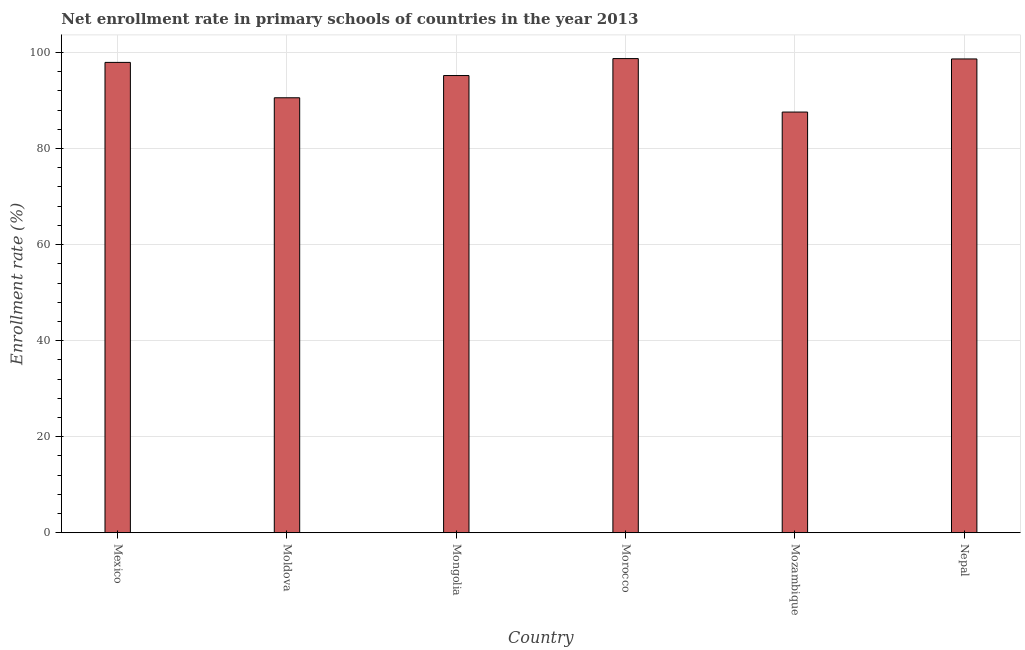Does the graph contain grids?
Ensure brevity in your answer.  Yes. What is the title of the graph?
Give a very brief answer. Net enrollment rate in primary schools of countries in the year 2013. What is the label or title of the X-axis?
Offer a terse response. Country. What is the label or title of the Y-axis?
Make the answer very short. Enrollment rate (%). What is the net enrollment rate in primary schools in Morocco?
Make the answer very short. 98.74. Across all countries, what is the maximum net enrollment rate in primary schools?
Give a very brief answer. 98.74. Across all countries, what is the minimum net enrollment rate in primary schools?
Keep it short and to the point. 87.61. In which country was the net enrollment rate in primary schools maximum?
Your response must be concise. Morocco. In which country was the net enrollment rate in primary schools minimum?
Make the answer very short. Mozambique. What is the sum of the net enrollment rate in primary schools?
Provide a short and direct response. 568.75. What is the difference between the net enrollment rate in primary schools in Morocco and Mozambique?
Your answer should be compact. 11.14. What is the average net enrollment rate in primary schools per country?
Provide a succinct answer. 94.79. What is the median net enrollment rate in primary schools?
Offer a terse response. 96.58. In how many countries, is the net enrollment rate in primary schools greater than 92 %?
Give a very brief answer. 4. What is the ratio of the net enrollment rate in primary schools in Moldova to that in Mozambique?
Your answer should be compact. 1.03. Is the difference between the net enrollment rate in primary schools in Mongolia and Morocco greater than the difference between any two countries?
Provide a short and direct response. No. What is the difference between the highest and the second highest net enrollment rate in primary schools?
Your answer should be compact. 0.08. Is the sum of the net enrollment rate in primary schools in Moldova and Nepal greater than the maximum net enrollment rate in primary schools across all countries?
Provide a short and direct response. Yes. What is the difference between the highest and the lowest net enrollment rate in primary schools?
Offer a terse response. 11.14. In how many countries, is the net enrollment rate in primary schools greater than the average net enrollment rate in primary schools taken over all countries?
Your answer should be very brief. 4. How many bars are there?
Offer a terse response. 6. What is the Enrollment rate (%) in Mexico?
Your response must be concise. 97.95. What is the Enrollment rate (%) of Moldova?
Your answer should be very brief. 90.58. What is the Enrollment rate (%) in Mongolia?
Offer a very short reply. 95.21. What is the Enrollment rate (%) in Morocco?
Offer a very short reply. 98.74. What is the Enrollment rate (%) in Mozambique?
Keep it short and to the point. 87.61. What is the Enrollment rate (%) of Nepal?
Your answer should be very brief. 98.67. What is the difference between the Enrollment rate (%) in Mexico and Moldova?
Provide a short and direct response. 7.37. What is the difference between the Enrollment rate (%) in Mexico and Mongolia?
Provide a succinct answer. 2.74. What is the difference between the Enrollment rate (%) in Mexico and Morocco?
Your answer should be compact. -0.8. What is the difference between the Enrollment rate (%) in Mexico and Mozambique?
Your response must be concise. 10.34. What is the difference between the Enrollment rate (%) in Mexico and Nepal?
Provide a succinct answer. -0.72. What is the difference between the Enrollment rate (%) in Moldova and Mongolia?
Ensure brevity in your answer.  -4.63. What is the difference between the Enrollment rate (%) in Moldova and Morocco?
Offer a very short reply. -8.16. What is the difference between the Enrollment rate (%) in Moldova and Mozambique?
Ensure brevity in your answer.  2.97. What is the difference between the Enrollment rate (%) in Moldova and Nepal?
Provide a succinct answer. -8.09. What is the difference between the Enrollment rate (%) in Mongolia and Morocco?
Offer a terse response. -3.53. What is the difference between the Enrollment rate (%) in Mongolia and Mozambique?
Your answer should be very brief. 7.6. What is the difference between the Enrollment rate (%) in Mongolia and Nepal?
Ensure brevity in your answer.  -3.46. What is the difference between the Enrollment rate (%) in Morocco and Mozambique?
Offer a very short reply. 11.14. What is the difference between the Enrollment rate (%) in Morocco and Nepal?
Offer a very short reply. 0.08. What is the difference between the Enrollment rate (%) in Mozambique and Nepal?
Provide a short and direct response. -11.06. What is the ratio of the Enrollment rate (%) in Mexico to that in Moldova?
Offer a terse response. 1.08. What is the ratio of the Enrollment rate (%) in Mexico to that in Mongolia?
Your answer should be compact. 1.03. What is the ratio of the Enrollment rate (%) in Mexico to that in Morocco?
Keep it short and to the point. 0.99. What is the ratio of the Enrollment rate (%) in Mexico to that in Mozambique?
Give a very brief answer. 1.12. What is the ratio of the Enrollment rate (%) in Moldova to that in Mongolia?
Provide a succinct answer. 0.95. What is the ratio of the Enrollment rate (%) in Moldova to that in Morocco?
Your answer should be compact. 0.92. What is the ratio of the Enrollment rate (%) in Moldova to that in Mozambique?
Provide a short and direct response. 1.03. What is the ratio of the Enrollment rate (%) in Moldova to that in Nepal?
Your answer should be very brief. 0.92. What is the ratio of the Enrollment rate (%) in Mongolia to that in Morocco?
Ensure brevity in your answer.  0.96. What is the ratio of the Enrollment rate (%) in Mongolia to that in Mozambique?
Provide a succinct answer. 1.09. What is the ratio of the Enrollment rate (%) in Morocco to that in Mozambique?
Make the answer very short. 1.13. What is the ratio of the Enrollment rate (%) in Mozambique to that in Nepal?
Offer a terse response. 0.89. 